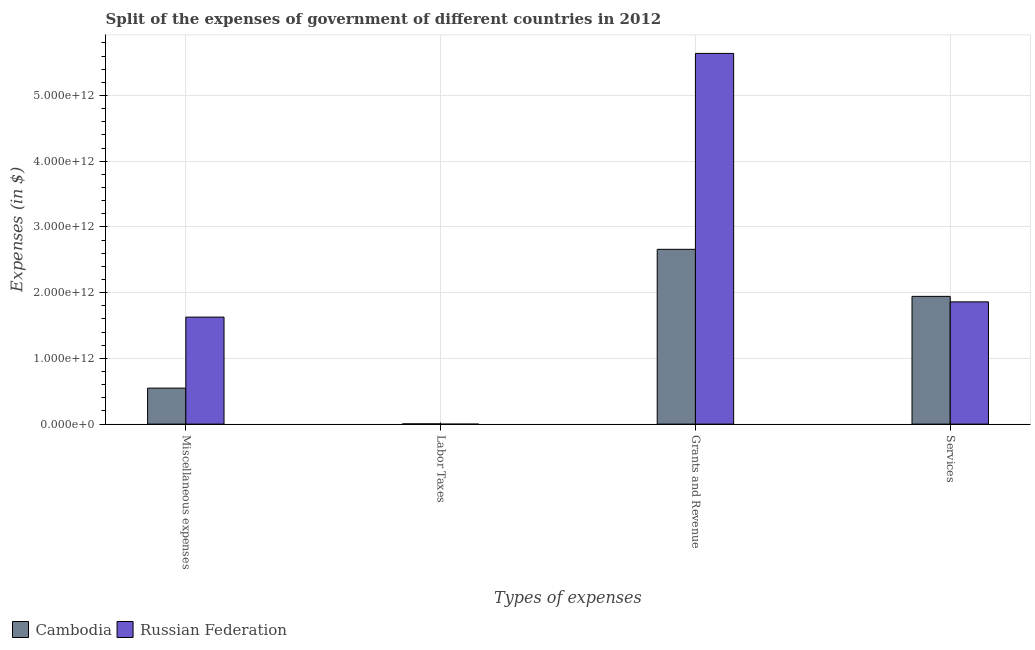How many bars are there on the 4th tick from the left?
Your answer should be compact. 2. How many bars are there on the 3rd tick from the right?
Provide a short and direct response. 1. What is the label of the 2nd group of bars from the left?
Make the answer very short. Labor Taxes. What is the amount spent on services in Cambodia?
Keep it short and to the point. 1.94e+12. Across all countries, what is the maximum amount spent on miscellaneous expenses?
Keep it short and to the point. 1.63e+12. Across all countries, what is the minimum amount spent on labor taxes?
Your answer should be compact. 0. In which country was the amount spent on grants and revenue maximum?
Your answer should be compact. Russian Federation. What is the total amount spent on labor taxes in the graph?
Make the answer very short. 3.65e+09. What is the difference between the amount spent on grants and revenue in Russian Federation and that in Cambodia?
Your answer should be compact. 2.98e+12. What is the difference between the amount spent on miscellaneous expenses in Cambodia and the amount spent on grants and revenue in Russian Federation?
Keep it short and to the point. -5.09e+12. What is the average amount spent on miscellaneous expenses per country?
Your answer should be very brief. 1.09e+12. What is the difference between the amount spent on services and amount spent on grants and revenue in Russian Federation?
Ensure brevity in your answer.  -3.78e+12. In how many countries, is the amount spent on services greater than 5200000000000 $?
Provide a short and direct response. 0. What is the ratio of the amount spent on grants and revenue in Cambodia to that in Russian Federation?
Give a very brief answer. 0.47. What is the difference between the highest and the second highest amount spent on miscellaneous expenses?
Ensure brevity in your answer.  1.08e+12. What is the difference between the highest and the lowest amount spent on grants and revenue?
Your answer should be very brief. 2.98e+12. Is it the case that in every country, the sum of the amount spent on miscellaneous expenses and amount spent on services is greater than the sum of amount spent on labor taxes and amount spent on grants and revenue?
Your answer should be very brief. No. Are all the bars in the graph horizontal?
Your answer should be compact. No. What is the difference between two consecutive major ticks on the Y-axis?
Give a very brief answer. 1.00e+12. Are the values on the major ticks of Y-axis written in scientific E-notation?
Your answer should be compact. Yes. Does the graph contain grids?
Keep it short and to the point. Yes. How many legend labels are there?
Offer a terse response. 2. What is the title of the graph?
Provide a succinct answer. Split of the expenses of government of different countries in 2012. What is the label or title of the X-axis?
Offer a terse response. Types of expenses. What is the label or title of the Y-axis?
Ensure brevity in your answer.  Expenses (in $). What is the Expenses (in $) of Cambodia in Miscellaneous expenses?
Provide a short and direct response. 5.48e+11. What is the Expenses (in $) of Russian Federation in Miscellaneous expenses?
Your answer should be compact. 1.63e+12. What is the Expenses (in $) in Cambodia in Labor Taxes?
Offer a very short reply. 3.65e+09. What is the Expenses (in $) of Cambodia in Grants and Revenue?
Provide a succinct answer. 2.66e+12. What is the Expenses (in $) in Russian Federation in Grants and Revenue?
Offer a terse response. 5.64e+12. What is the Expenses (in $) in Cambodia in Services?
Give a very brief answer. 1.94e+12. What is the Expenses (in $) of Russian Federation in Services?
Make the answer very short. 1.86e+12. Across all Types of expenses, what is the maximum Expenses (in $) of Cambodia?
Offer a terse response. 2.66e+12. Across all Types of expenses, what is the maximum Expenses (in $) in Russian Federation?
Provide a short and direct response. 5.64e+12. Across all Types of expenses, what is the minimum Expenses (in $) of Cambodia?
Provide a short and direct response. 3.65e+09. Across all Types of expenses, what is the minimum Expenses (in $) of Russian Federation?
Your answer should be very brief. 0. What is the total Expenses (in $) in Cambodia in the graph?
Provide a succinct answer. 5.16e+12. What is the total Expenses (in $) of Russian Federation in the graph?
Your answer should be compact. 9.13e+12. What is the difference between the Expenses (in $) in Cambodia in Miscellaneous expenses and that in Labor Taxes?
Your response must be concise. 5.44e+11. What is the difference between the Expenses (in $) of Cambodia in Miscellaneous expenses and that in Grants and Revenue?
Your answer should be very brief. -2.11e+12. What is the difference between the Expenses (in $) in Russian Federation in Miscellaneous expenses and that in Grants and Revenue?
Your answer should be very brief. -4.01e+12. What is the difference between the Expenses (in $) of Cambodia in Miscellaneous expenses and that in Services?
Your response must be concise. -1.40e+12. What is the difference between the Expenses (in $) of Russian Federation in Miscellaneous expenses and that in Services?
Give a very brief answer. -2.32e+11. What is the difference between the Expenses (in $) in Cambodia in Labor Taxes and that in Grants and Revenue?
Your answer should be very brief. -2.66e+12. What is the difference between the Expenses (in $) in Cambodia in Labor Taxes and that in Services?
Make the answer very short. -1.94e+12. What is the difference between the Expenses (in $) in Cambodia in Grants and Revenue and that in Services?
Your answer should be compact. 7.16e+11. What is the difference between the Expenses (in $) in Russian Federation in Grants and Revenue and that in Services?
Your answer should be compact. 3.78e+12. What is the difference between the Expenses (in $) in Cambodia in Miscellaneous expenses and the Expenses (in $) in Russian Federation in Grants and Revenue?
Make the answer very short. -5.09e+12. What is the difference between the Expenses (in $) in Cambodia in Miscellaneous expenses and the Expenses (in $) in Russian Federation in Services?
Offer a very short reply. -1.31e+12. What is the difference between the Expenses (in $) of Cambodia in Labor Taxes and the Expenses (in $) of Russian Federation in Grants and Revenue?
Provide a short and direct response. -5.64e+12. What is the difference between the Expenses (in $) in Cambodia in Labor Taxes and the Expenses (in $) in Russian Federation in Services?
Ensure brevity in your answer.  -1.86e+12. What is the difference between the Expenses (in $) of Cambodia in Grants and Revenue and the Expenses (in $) of Russian Federation in Services?
Make the answer very short. 8.00e+11. What is the average Expenses (in $) of Cambodia per Types of expenses?
Ensure brevity in your answer.  1.29e+12. What is the average Expenses (in $) in Russian Federation per Types of expenses?
Give a very brief answer. 2.28e+12. What is the difference between the Expenses (in $) of Cambodia and Expenses (in $) of Russian Federation in Miscellaneous expenses?
Offer a terse response. -1.08e+12. What is the difference between the Expenses (in $) of Cambodia and Expenses (in $) of Russian Federation in Grants and Revenue?
Your answer should be compact. -2.98e+12. What is the difference between the Expenses (in $) of Cambodia and Expenses (in $) of Russian Federation in Services?
Make the answer very short. 8.37e+1. What is the ratio of the Expenses (in $) in Cambodia in Miscellaneous expenses to that in Labor Taxes?
Offer a terse response. 150.28. What is the ratio of the Expenses (in $) of Cambodia in Miscellaneous expenses to that in Grants and Revenue?
Offer a terse response. 0.21. What is the ratio of the Expenses (in $) in Russian Federation in Miscellaneous expenses to that in Grants and Revenue?
Your answer should be very brief. 0.29. What is the ratio of the Expenses (in $) of Cambodia in Miscellaneous expenses to that in Services?
Your answer should be very brief. 0.28. What is the ratio of the Expenses (in $) of Russian Federation in Miscellaneous expenses to that in Services?
Make the answer very short. 0.88. What is the ratio of the Expenses (in $) of Cambodia in Labor Taxes to that in Grants and Revenue?
Make the answer very short. 0. What is the ratio of the Expenses (in $) in Cambodia in Labor Taxes to that in Services?
Your response must be concise. 0. What is the ratio of the Expenses (in $) in Cambodia in Grants and Revenue to that in Services?
Keep it short and to the point. 1.37. What is the ratio of the Expenses (in $) in Russian Federation in Grants and Revenue to that in Services?
Provide a short and direct response. 3.03. What is the difference between the highest and the second highest Expenses (in $) in Cambodia?
Ensure brevity in your answer.  7.16e+11. What is the difference between the highest and the second highest Expenses (in $) of Russian Federation?
Provide a succinct answer. 3.78e+12. What is the difference between the highest and the lowest Expenses (in $) of Cambodia?
Give a very brief answer. 2.66e+12. What is the difference between the highest and the lowest Expenses (in $) in Russian Federation?
Your response must be concise. 5.64e+12. 